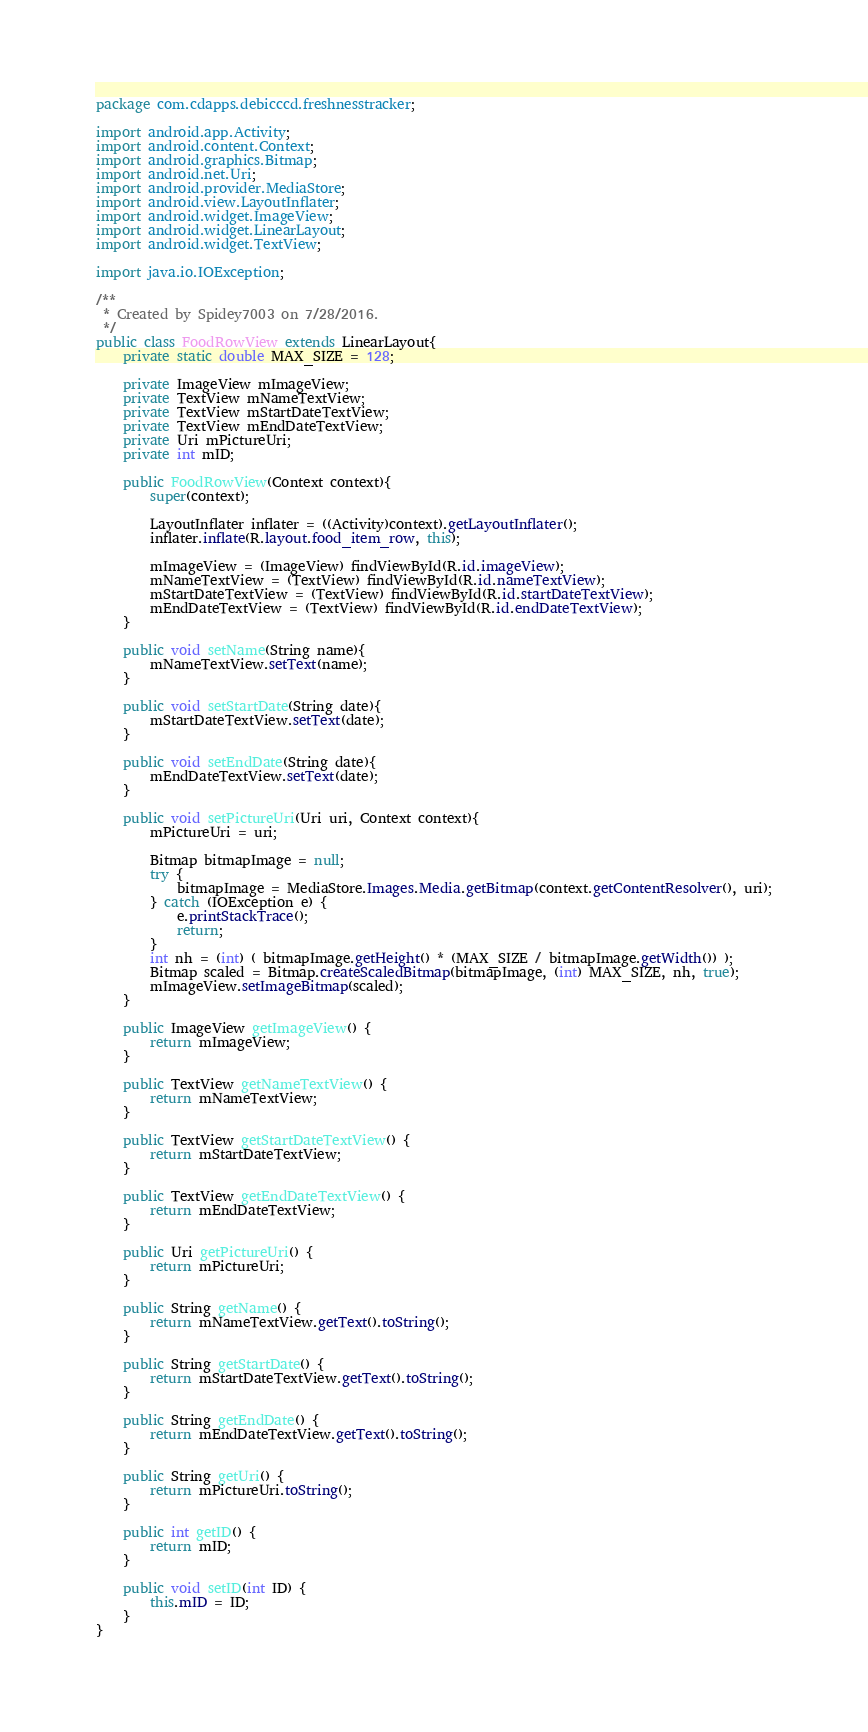Convert code to text. <code><loc_0><loc_0><loc_500><loc_500><_Java_>package com.cdapps.debicccd.freshnesstracker;

import android.app.Activity;
import android.content.Context;
import android.graphics.Bitmap;
import android.net.Uri;
import android.provider.MediaStore;
import android.view.LayoutInflater;
import android.widget.ImageView;
import android.widget.LinearLayout;
import android.widget.TextView;

import java.io.IOException;

/**
 * Created by Spidey7003 on 7/28/2016.
 */
public class FoodRowView extends LinearLayout{
    private static double MAX_SIZE = 128;

    private ImageView mImageView;
    private TextView mNameTextView;
    private TextView mStartDateTextView;
    private TextView mEndDateTextView;
    private Uri mPictureUri;
    private int mID;

    public FoodRowView(Context context){
        super(context);

        LayoutInflater inflater = ((Activity)context).getLayoutInflater();
        inflater.inflate(R.layout.food_item_row, this);

        mImageView = (ImageView) findViewById(R.id.imageView);
        mNameTextView = (TextView) findViewById(R.id.nameTextView);
        mStartDateTextView = (TextView) findViewById(R.id.startDateTextView);
        mEndDateTextView = (TextView) findViewById(R.id.endDateTextView);
    }

    public void setName(String name){
        mNameTextView.setText(name);
    }

    public void setStartDate(String date){
        mStartDateTextView.setText(date);
    }

    public void setEndDate(String date){
        mEndDateTextView.setText(date);
    }

    public void setPictureUri(Uri uri, Context context){
        mPictureUri = uri;

        Bitmap bitmapImage = null;
        try {
            bitmapImage = MediaStore.Images.Media.getBitmap(context.getContentResolver(), uri);
        } catch (IOException e) {
            e.printStackTrace();
            return;
        }
        int nh = (int) ( bitmapImage.getHeight() * (MAX_SIZE / bitmapImage.getWidth()) );
        Bitmap scaled = Bitmap.createScaledBitmap(bitmapImage, (int) MAX_SIZE, nh, true);
        mImageView.setImageBitmap(scaled);
    }

    public ImageView getImageView() {
        return mImageView;
    }

    public TextView getNameTextView() {
        return mNameTextView;
    }

    public TextView getStartDateTextView() {
        return mStartDateTextView;
    }

    public TextView getEndDateTextView() {
        return mEndDateTextView;
    }

    public Uri getPictureUri() {
        return mPictureUri;
    }

    public String getName() {
        return mNameTextView.getText().toString();
    }

    public String getStartDate() {
        return mStartDateTextView.getText().toString();
    }

    public String getEndDate() {
        return mEndDateTextView.getText().toString();
    }

    public String getUri() {
        return mPictureUri.toString();
    }

    public int getID() {
        return mID;
    }

    public void setID(int ID) {
        this.mID = ID;
    }
}
</code> 